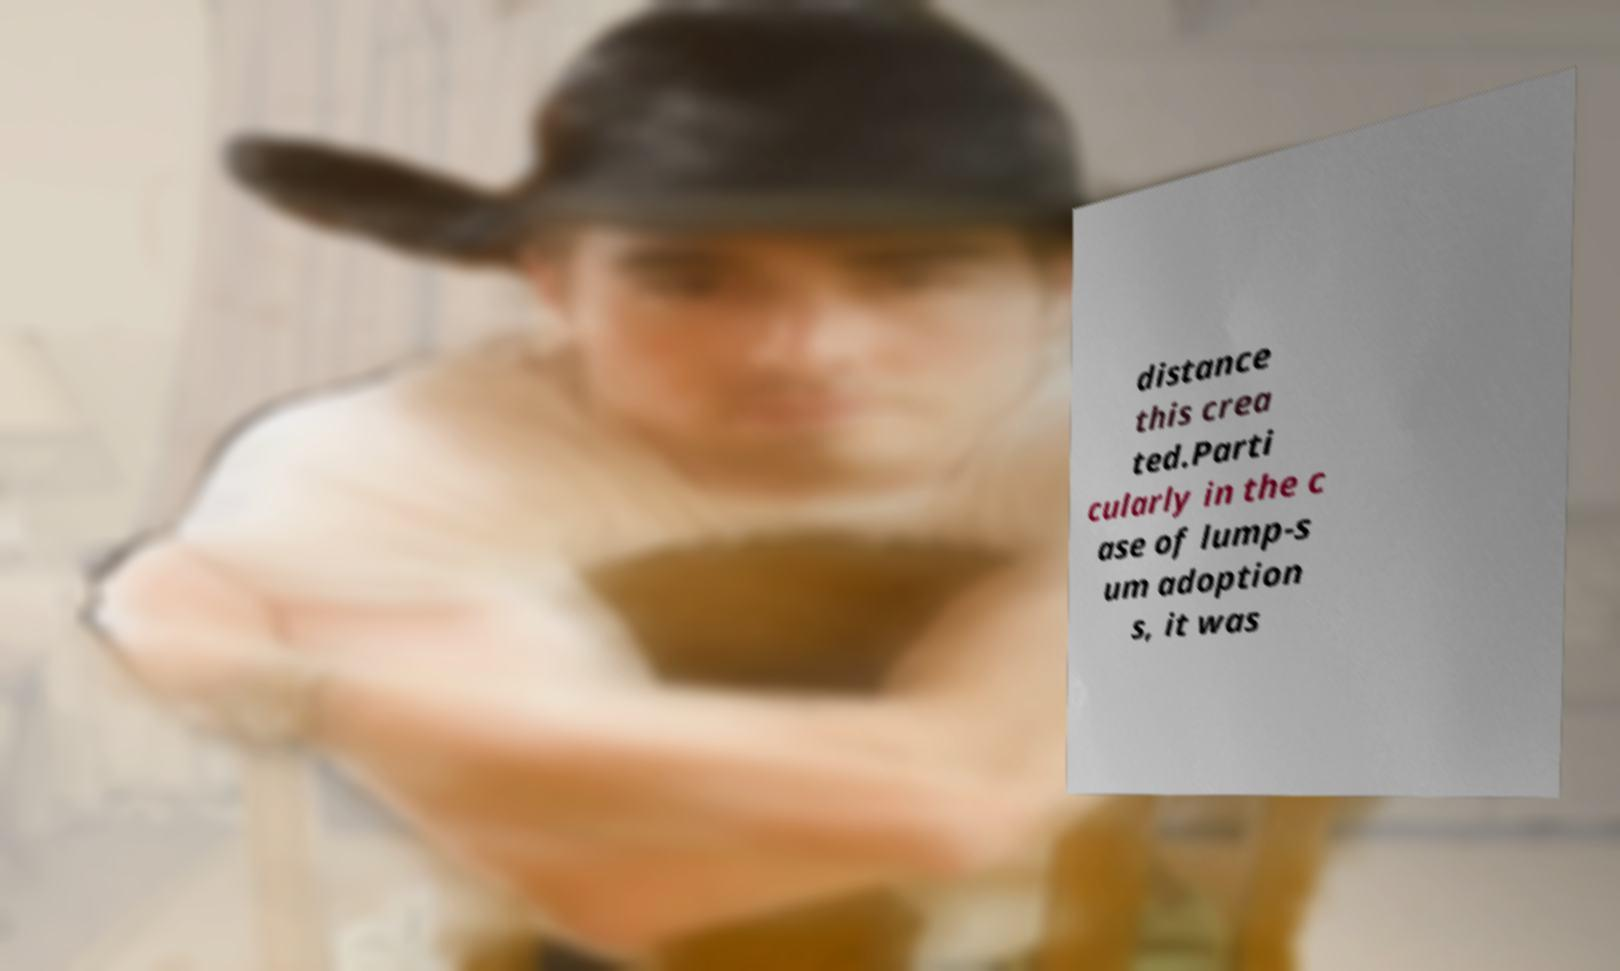What messages or text are displayed in this image? I need them in a readable, typed format. distance this crea ted.Parti cularly in the c ase of lump-s um adoption s, it was 